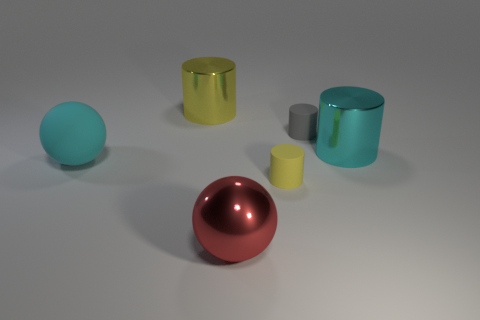Subtract all gray cubes. How many yellow cylinders are left? 2 Subtract all small gray rubber cylinders. How many cylinders are left? 3 Subtract 1 cylinders. How many cylinders are left? 3 Subtract all cyan cylinders. How many cylinders are left? 3 Add 3 big red shiny objects. How many objects exist? 9 Subtract all cylinders. How many objects are left? 2 Subtract all blue cylinders. Subtract all green balls. How many cylinders are left? 4 Subtract all big purple shiny cubes. Subtract all big yellow shiny cylinders. How many objects are left? 5 Add 2 big red metal balls. How many big red metal balls are left? 3 Add 5 green matte spheres. How many green matte spheres exist? 5 